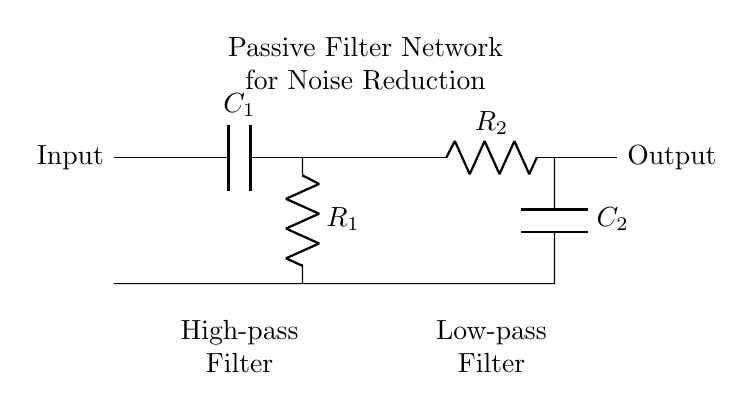What are the components in the circuit? The circuit contains two resistors and two capacitors, specifically labeled as R1, R2, C1, and C2.
Answer: R1, R2, C1, C2 What type of filter does R1 and C1 form? R1 and C1 are arranged to allow high-frequency signals to pass while attenuating low-frequency signals, classifying this as a high-pass filter.
Answer: High-pass filter What is the purpose of C2 and R2 in the circuit? C2 and R2 create a low-pass filter that allows low-frequency signals to pass through while attenuating high-frequency signals.
Answer: Low-pass filter How many filters are present in this circuit? There are two filters in the circuit: a high-pass filter and a low-pass filter.
Answer: Two Which component directly connects the output to the low-pass filter? The low-pass filter is directly connected to the output through the second resistor R2.
Answer: R2 What is the structure of the passive filter network in this circuit? The passive filter network consists of a high-pass filter followed by a low-pass filter, effectively forming a cascaded system for noise reduction.
Answer: Cascaded system 